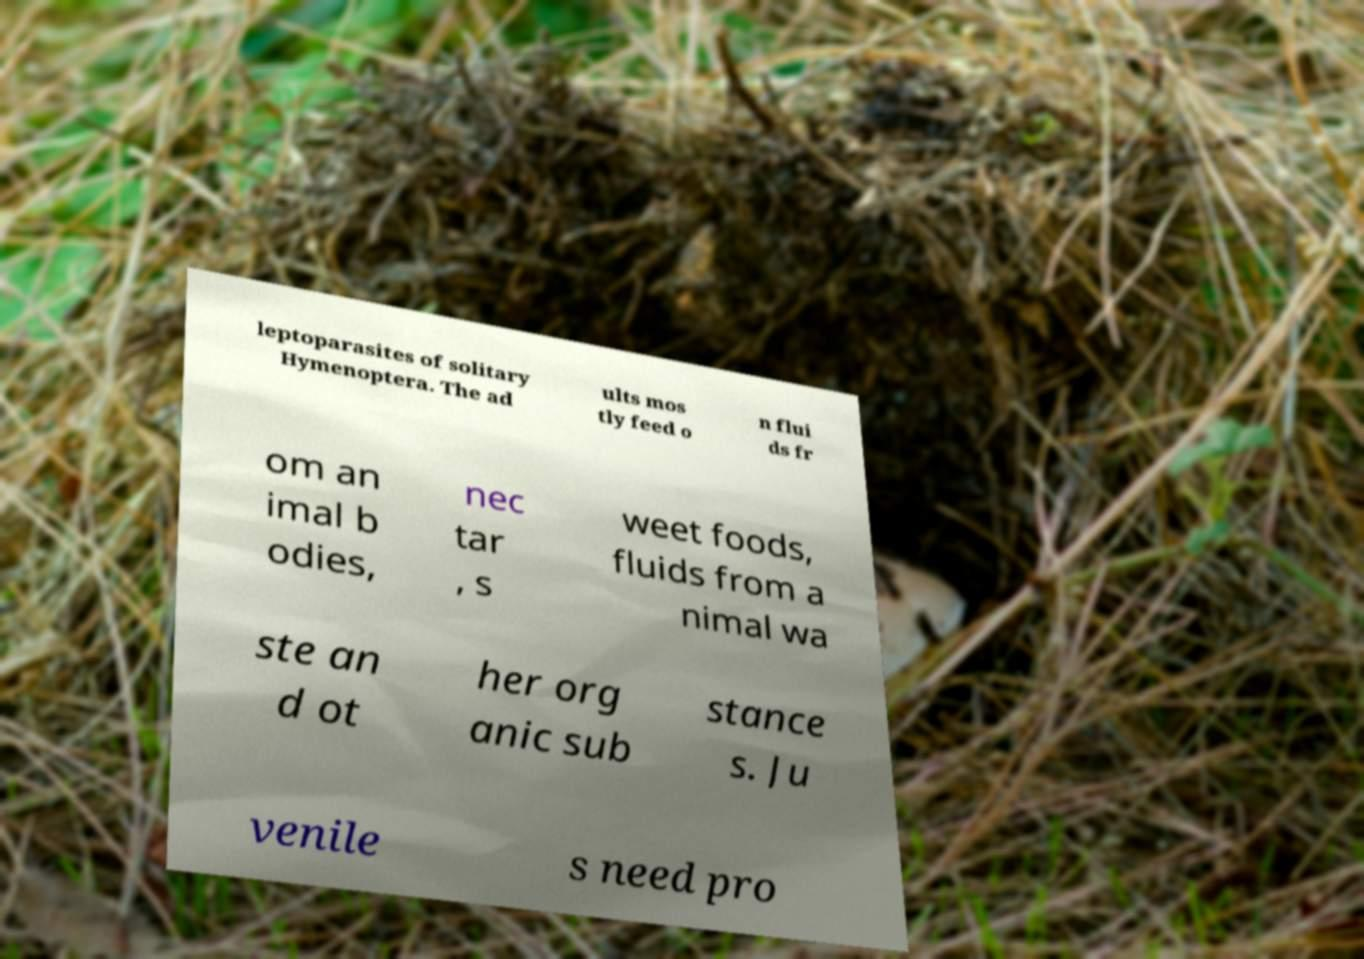There's text embedded in this image that I need extracted. Can you transcribe it verbatim? leptoparasites of solitary Hymenoptera. The ad ults mos tly feed o n flui ds fr om an imal b odies, nec tar , s weet foods, fluids from a nimal wa ste an d ot her org anic sub stance s. Ju venile s need pro 